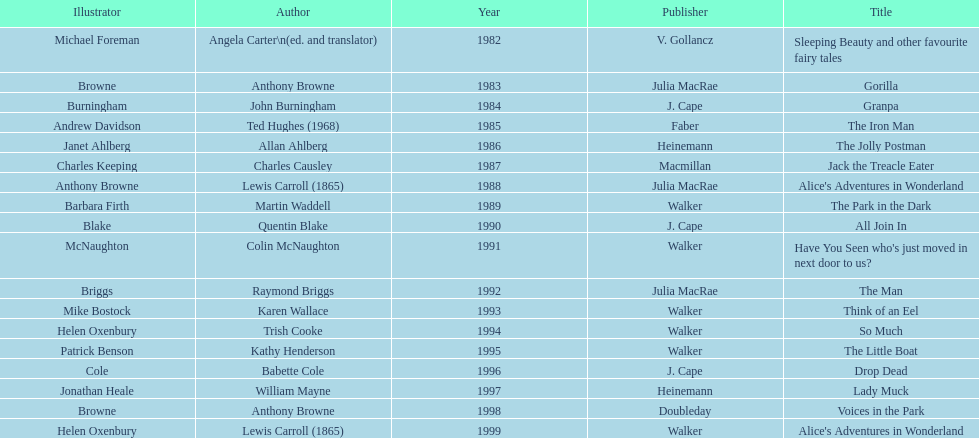How many titles had the same author listed as the illustrator? 7. 